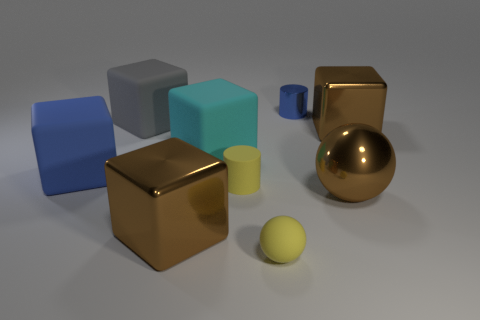How many large shiny blocks are in front of the block on the right side of the small blue cylinder?
Your answer should be very brief. 1. There is a blue metal cylinder; is it the same size as the brown metal block that is left of the yellow ball?
Your answer should be very brief. No. Are there any large rubber blocks of the same color as the tiny matte sphere?
Provide a succinct answer. No. There is a ball that is the same material as the small blue object; what is its size?
Keep it short and to the point. Large. Is the cyan thing made of the same material as the yellow ball?
Your answer should be very brief. Yes. There is a metallic cube that is right of the rubber thing that is in front of the big metal cube to the left of the blue cylinder; what is its color?
Keep it short and to the point. Brown. The large gray object has what shape?
Provide a succinct answer. Cube. Does the small metal cylinder have the same color as the cylinder that is in front of the gray matte block?
Your answer should be very brief. No. Is the number of tiny blue metallic objects that are to the left of the small rubber sphere the same as the number of big gray rubber blocks?
Your response must be concise. No. How many green blocks are the same size as the yellow rubber ball?
Make the answer very short. 0. 